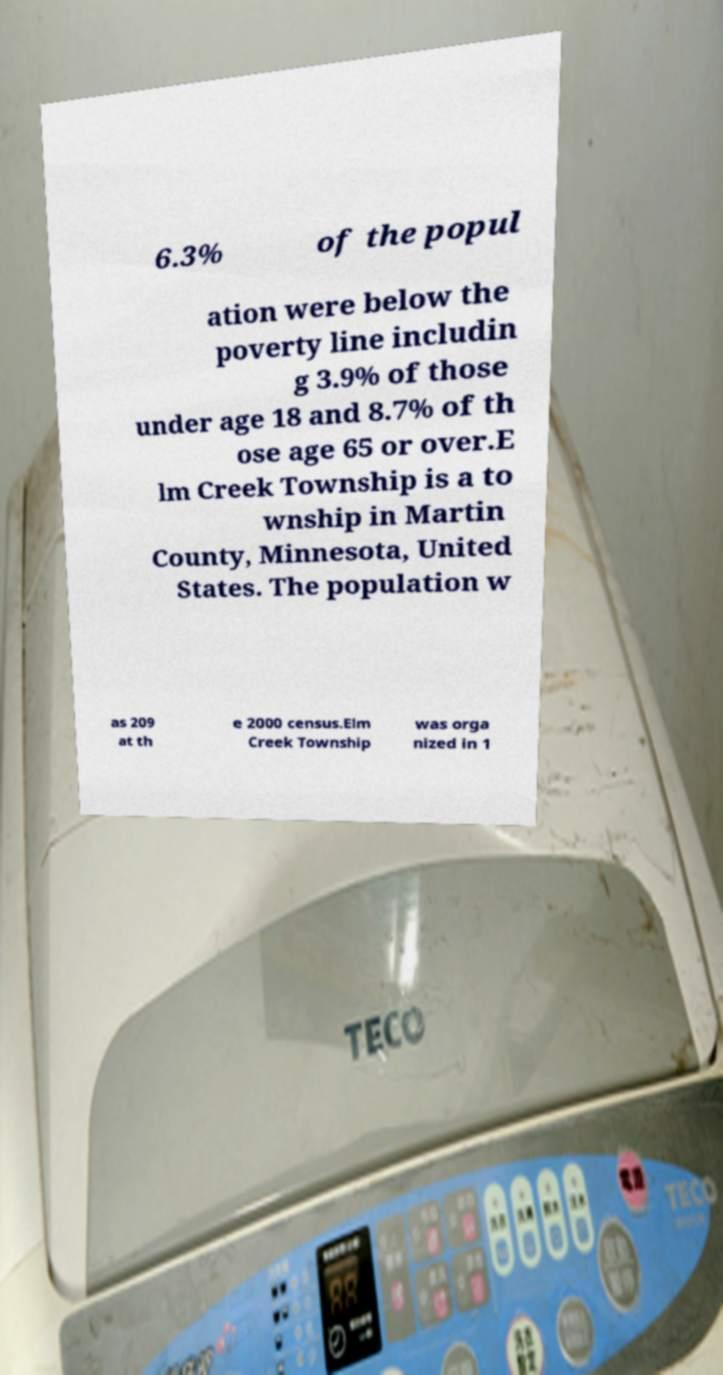Can you accurately transcribe the text from the provided image for me? 6.3% of the popul ation were below the poverty line includin g 3.9% of those under age 18 and 8.7% of th ose age 65 or over.E lm Creek Township is a to wnship in Martin County, Minnesota, United States. The population w as 209 at th e 2000 census.Elm Creek Township was orga nized in 1 